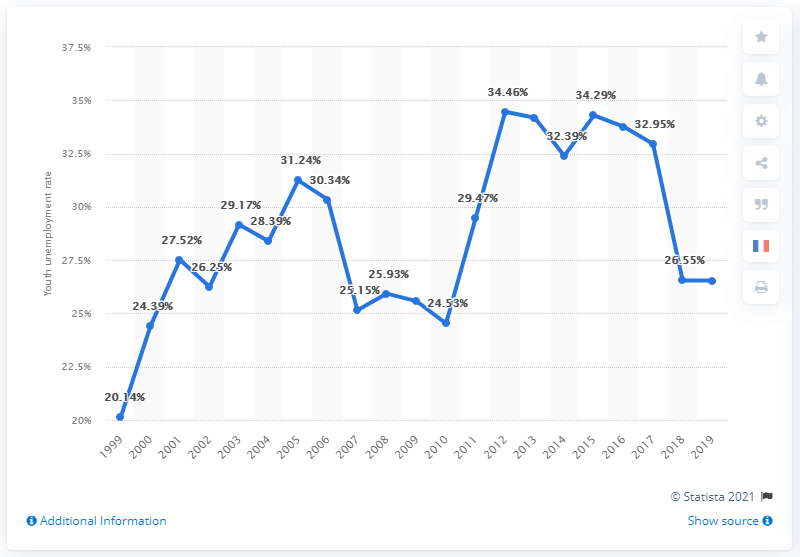Draw attention to some important aspects in this diagram. In 2019, the youth unemployment rate in Egypt was 26.54%. 